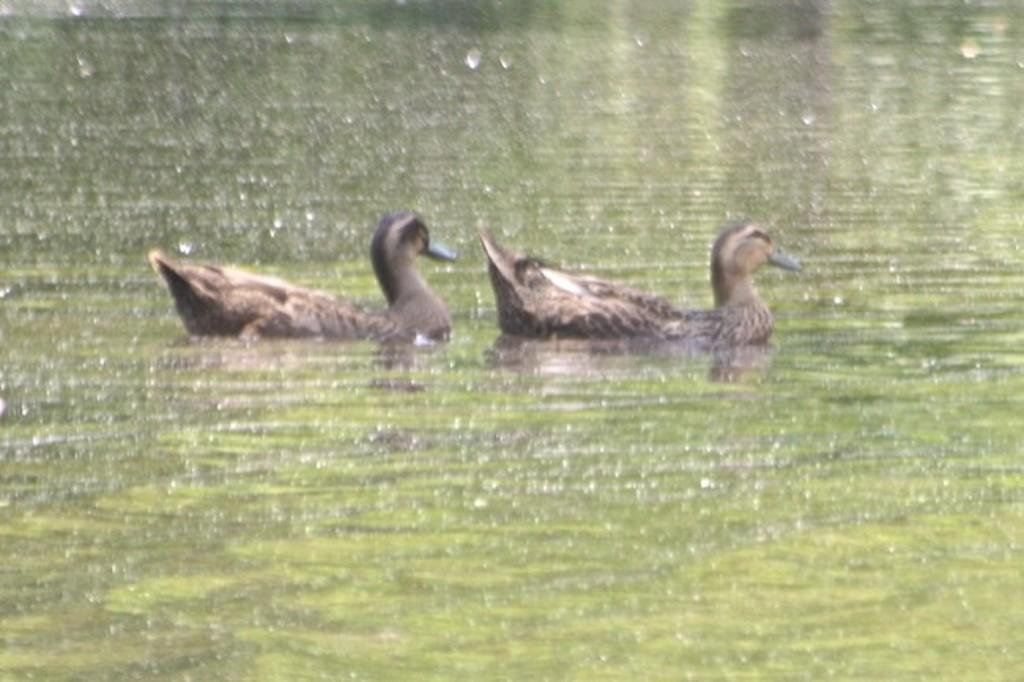What type of animals are in the image? There are ducks in the image. Where are the ducks located? The ducks are in the water. What type of bomb can be seen in the image? There is no bomb present in the image; it features ducks in the water. Is there a train visible in the image? No, there is no train present in the image. 